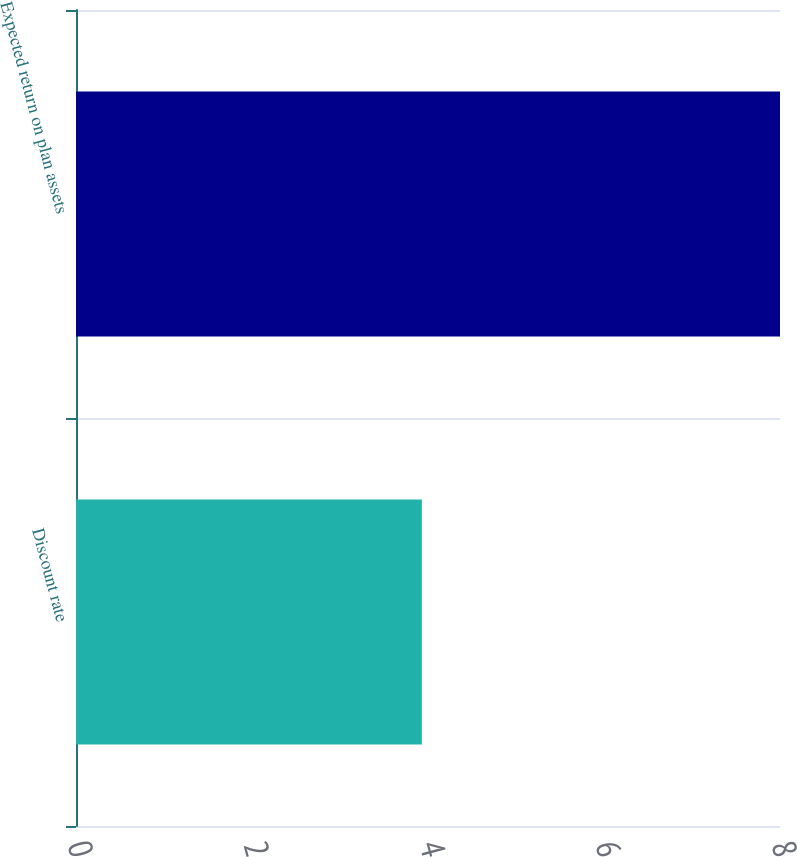<chart> <loc_0><loc_0><loc_500><loc_500><bar_chart><fcel>Discount rate<fcel>Expected return on plan assets<nl><fcel>3.93<fcel>8<nl></chart> 